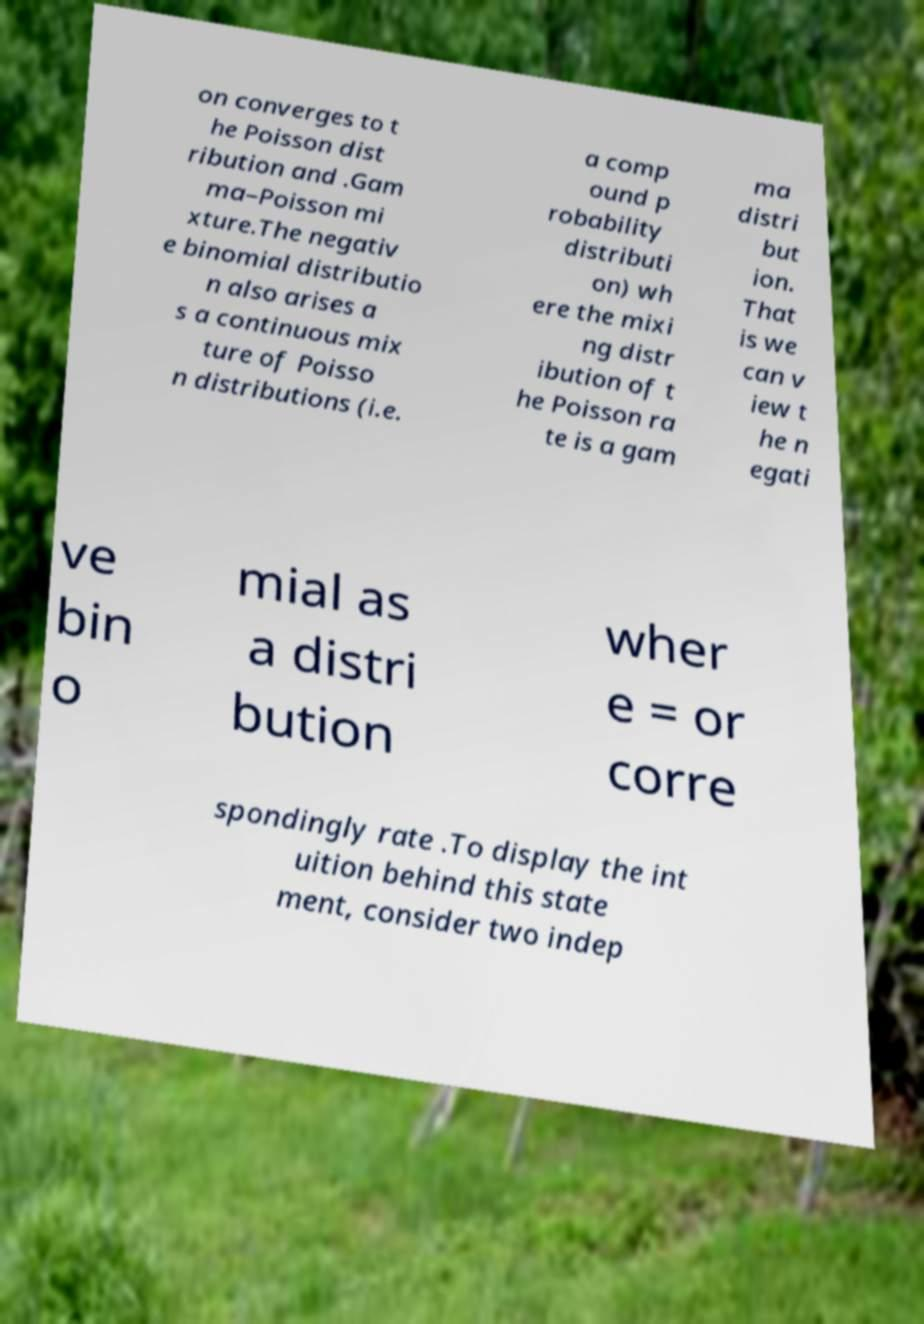Please read and relay the text visible in this image. What does it say? on converges to t he Poisson dist ribution and .Gam ma–Poisson mi xture.The negativ e binomial distributio n also arises a s a continuous mix ture of Poisso n distributions (i.e. a comp ound p robability distributi on) wh ere the mixi ng distr ibution of t he Poisson ra te is a gam ma distri but ion. That is we can v iew t he n egati ve bin o mial as a distri bution wher e = or corre spondingly rate .To display the int uition behind this state ment, consider two indep 